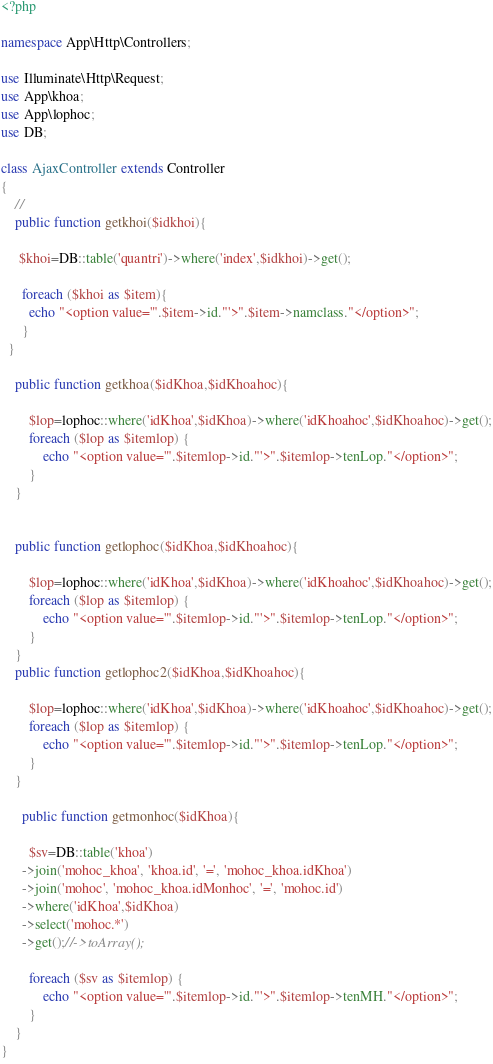Convert code to text. <code><loc_0><loc_0><loc_500><loc_500><_PHP_><?php

namespace App\Http\Controllers;

use Illuminate\Http\Request;
use App\khoa;
use App\lophoc;
use DB;

class AjaxController extends Controller
{
    //
    public function getkhoi($idkhoi){

     $khoi=DB::table('quantri')->where('index',$idkhoi)->get();

      foreach ($khoi as $item){
      	echo "<option value='".$item->id."'>".$item->namclass."</option>";
      }
  }

    public function getkhoa($idKhoa,$idKhoahoc){

		$lop=lophoc::where('idKhoa',$idKhoa)->where('idKhoahoc',$idKhoahoc)->get();
		foreach ($lop as $itemlop) {
			echo "<option value='".$itemlop->id."'>".$itemlop->tenLop."</option>";
		}
	}

	
	public function getlophoc($idKhoa,$idKhoahoc){

		$lop=lophoc::where('idKhoa',$idKhoa)->where('idKhoahoc',$idKhoahoc)->get();
		foreach ($lop as $itemlop) {
			echo "<option value='".$itemlop->id."'>".$itemlop->tenLop."</option>";
		}
	}
	public function getlophoc2($idKhoa,$idKhoahoc){

		$lop=lophoc::where('idKhoa',$idKhoa)->where('idKhoahoc',$idKhoahoc)->get();
		foreach ($lop as $itemlop) {
			echo "<option value='".$itemlop->id."'>".$itemlop->tenLop."</option>";
		}
	}

	  public function getmonhoc($idKhoa){

	  	$sv=DB::table('khoa')
      ->join('mohoc_khoa', 'khoa.id', '=', 'mohoc_khoa.idKhoa')
      ->join('mohoc', 'mohoc_khoa.idMonhoc', '=', 'mohoc.id')
      ->where('idKhoa',$idKhoa)
      ->select('mohoc.*')
      ->get();//->toArray();
    
		foreach ($sv as $itemlop) {
			echo "<option value='".$itemlop->id."'>".$itemlop->tenMH."</option>";
		}
	}
}
</code> 